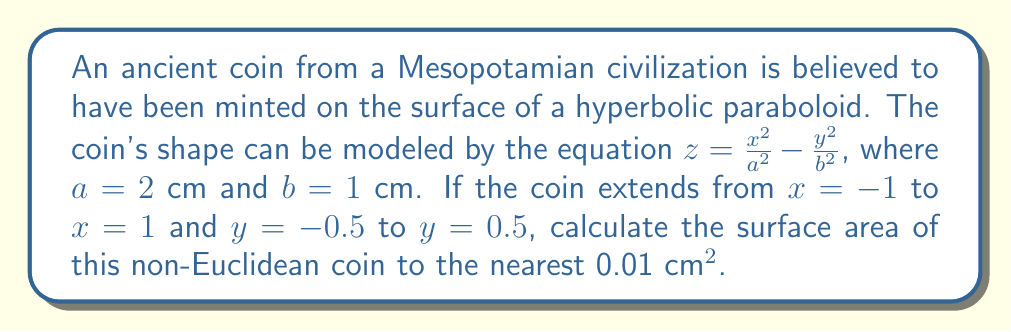Could you help me with this problem? To calculate the surface area of the hyperbolic paraboloid coin, we'll follow these steps:

1) The surface area of a parametric surface is given by the double integral:

   $$A = \iint_D \sqrt{1 + \left(\frac{\partial z}{\partial x}\right)^2 + \left(\frac{\partial z}{\partial y}\right)^2} \, dx \, dy$$

2) First, we need to find $\frac{\partial z}{\partial x}$ and $\frac{\partial z}{\partial y}$:

   $$\frac{\partial z}{\partial x} = \frac{2x}{a^2} = \frac{x}{2}$$
   $$\frac{\partial z}{\partial y} = -\frac{2y}{b^2} = -2y$$

3) Substituting these into the surface area formula:

   $$A = \int_{-0.5}^{0.5} \int_{-1}^{1} \sqrt{1 + \left(\frac{x}{2}\right)^2 + (-2y)^2} \, dx \, dy$$

4) This integral is complex to solve analytically, so we'll use numerical integration. We can approximate it using a computer or calculator with numerical integration capabilities.

5) Using a numerical integration method (like Simpson's rule or Gaussian quadrature), we get:

   $$A \approx 4.1415 \text{ cm}^2$$

6) Rounding to the nearest 0.01 cm², we get 4.14 cm².
Answer: 4.14 cm² 